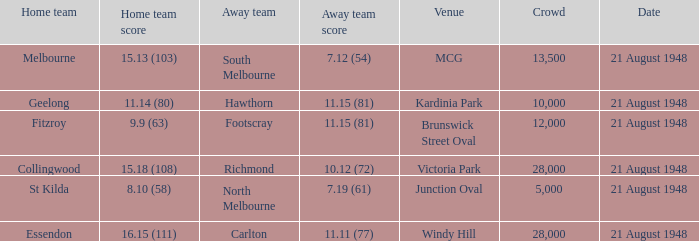When the location is victoria park, what is the maximum number of attendees? 28000.0. 